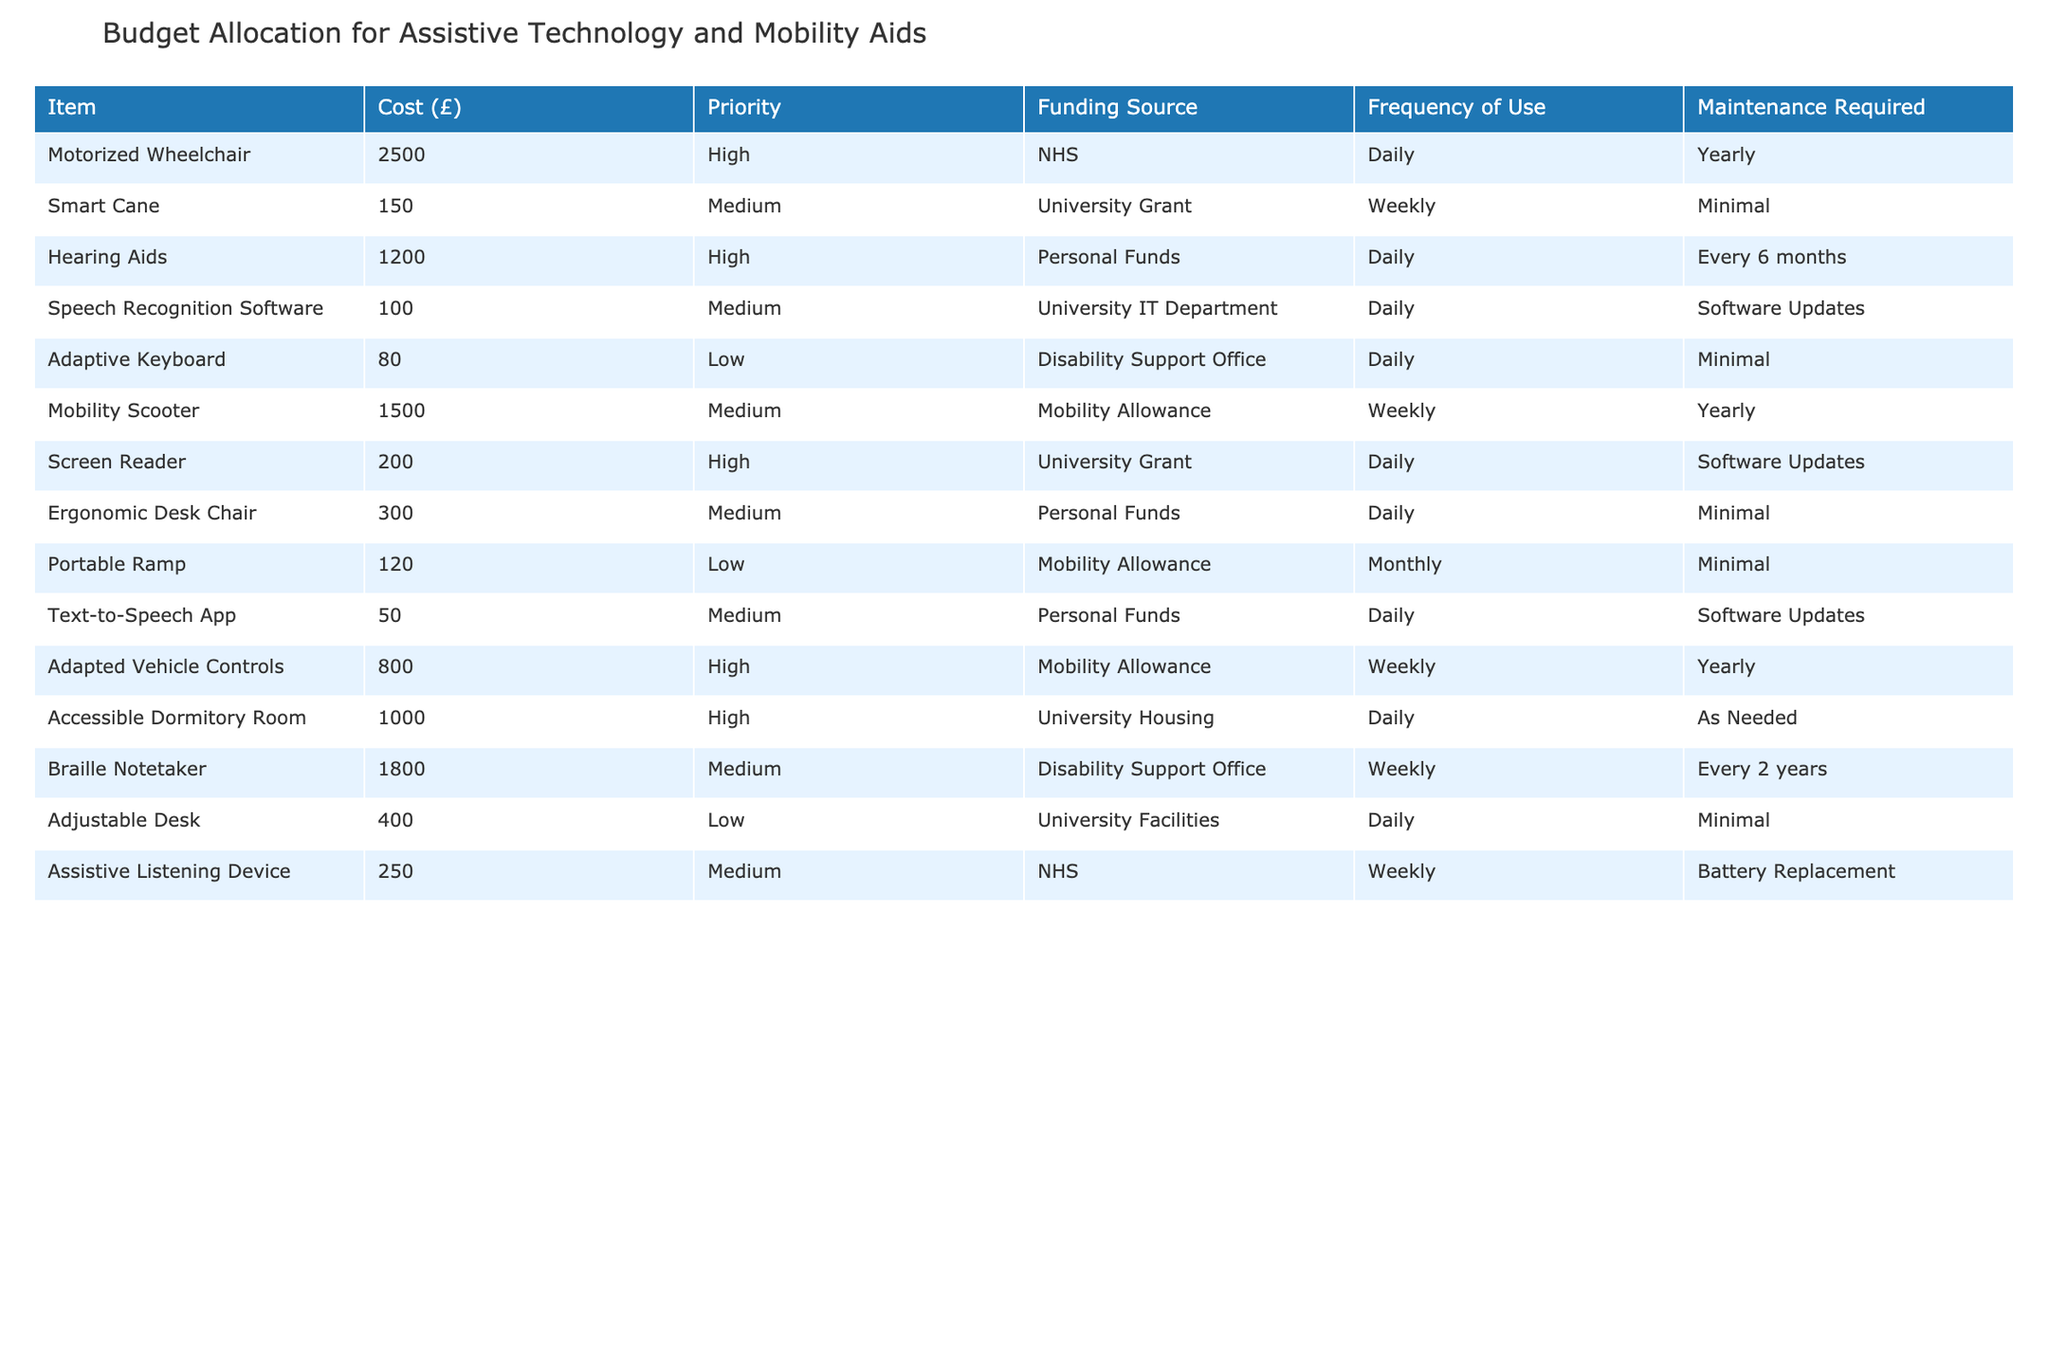What is the cost of the Motorized Wheelchair? The cost of the Motorized Wheelchair is listed in the table under the "Cost (£)" column next to the item's name. The value is 2500.
Answer: 2500 How often is the Adapted Vehicle Controls used? The frequency of use for the Adapted Vehicle Controls is indicated in the table under the "Frequency of Use" column. It shows that it is used weekly.
Answer: Weekly Which items require minimal maintenance? Items that require minimal maintenance are those categorized under the "Maintenance Required" column with the word "Minimal." These include Smart Cane, Adaptive Keyboard, Portable Ramp, and Ergonomic Desk Chair.
Answer: Smart Cane, Adaptive Keyboard, Portable Ramp, Ergonomic Desk Chair What is the total cost of all items labeled as 'High' priority? To determine the total cost of items with 'High' priority, we look for the costs of Motorized Wheelchair (2500), Hearing Aids (1200), Screen Reader (200), Adapted Vehicle Controls (800), and Accessible Dormitory Room (1000). Adding these gives us 2500 + 1200 + 200 + 800 + 1000 = 4700.
Answer: 4700 Is the Smart Cane more expensive than the Text-to-Speech App? We check the costs listed in the table: Smart Cane costs 150 while Text-to-Speech App costs 50. Since 150 is greater than 50, the answer is yes.
Answer: Yes Which funding source covers the highest number of items? We analyze the "Funding Source" column for repetitions. NHS appears 3 times (Motorized Wheelchair, Assistive Listening Device), Mobility Allowance appears 3 times (Mobility Scooter, Adapted Vehicle Controls, Portable Ramp), and Personal Funds appears 3 times (Hearing Aids, Ergonomic Desk Chair, Text-to-Speech App). There is a tie among NHS, Mobility Allowance, and Personal Funds with 3 items each.
Answer: NHS, Mobility Allowance, Personal Funds What item has the lowest cost, and how often is it used? The lowest cost in the "Cost (£)" column is for the Text-to-Speech App, which is 50. The usage frequency listed in the "Frequency of Use" column is daily.
Answer: Text-to-Speech App, Daily How much more does the Accessible Dormitory Room cost compared to the Adaptive Keyboard? The Accessible Dormitory Room costs 1000 and the Adaptive Keyboard costs 80. To find the difference, we subtract: 1000 - 80 = 920.
Answer: 920 Are all items with 'Medium' priority funded by university sources? By examining the "Funding Source" for items with 'Medium' priority, we find instances where funding comes from Personal Funds and Mobility Allowance as well. Therefore, not all items with 'Medium' priority are funded by university sources.
Answer: No 